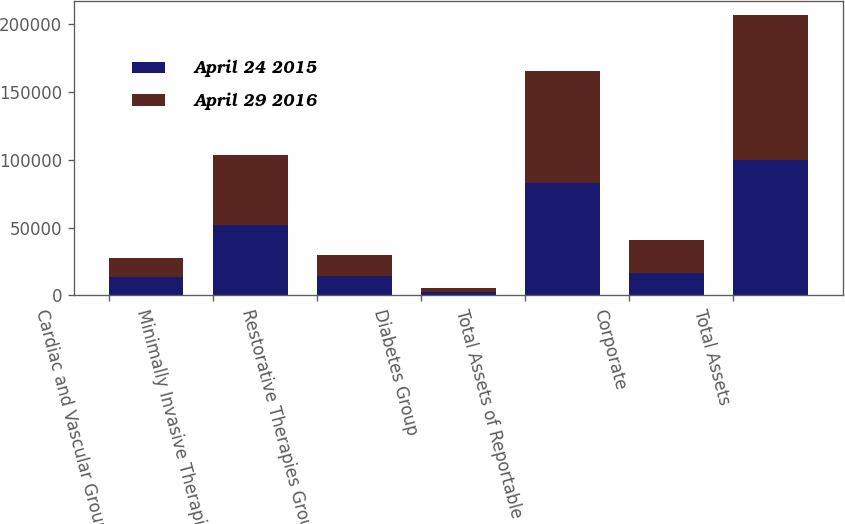<chart> <loc_0><loc_0><loc_500><loc_500><stacked_bar_chart><ecel><fcel>Cardiac and Vascular Group<fcel>Minimally Invasive Therapies<fcel>Restorative Therapies Group<fcel>Diabetes Group<fcel>Total Assets of Reportable<fcel>Corporate<fcel>Total Assets<nl><fcel>April 24 2015<fcel>13563<fcel>52227<fcel>14564<fcel>2592<fcel>82946<fcel>16836<fcel>99782<nl><fcel>April 29 2016<fcel>13642<fcel>51228<fcel>15249<fcel>2597<fcel>82716<fcel>23969<fcel>106685<nl></chart> 